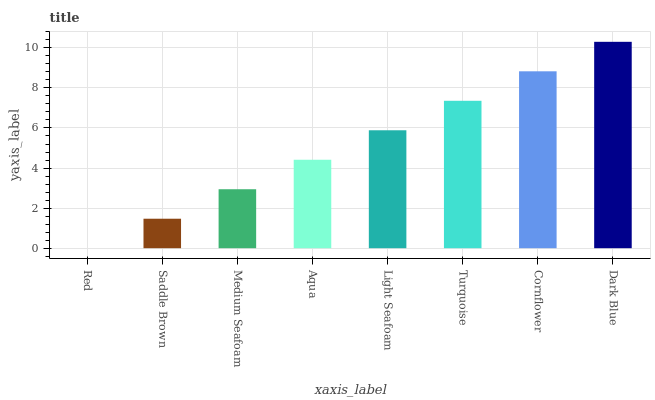Is Saddle Brown the minimum?
Answer yes or no. No. Is Saddle Brown the maximum?
Answer yes or no. No. Is Saddle Brown greater than Red?
Answer yes or no. Yes. Is Red less than Saddle Brown?
Answer yes or no. Yes. Is Red greater than Saddle Brown?
Answer yes or no. No. Is Saddle Brown less than Red?
Answer yes or no. No. Is Light Seafoam the high median?
Answer yes or no. Yes. Is Aqua the low median?
Answer yes or no. Yes. Is Turquoise the high median?
Answer yes or no. No. Is Red the low median?
Answer yes or no. No. 